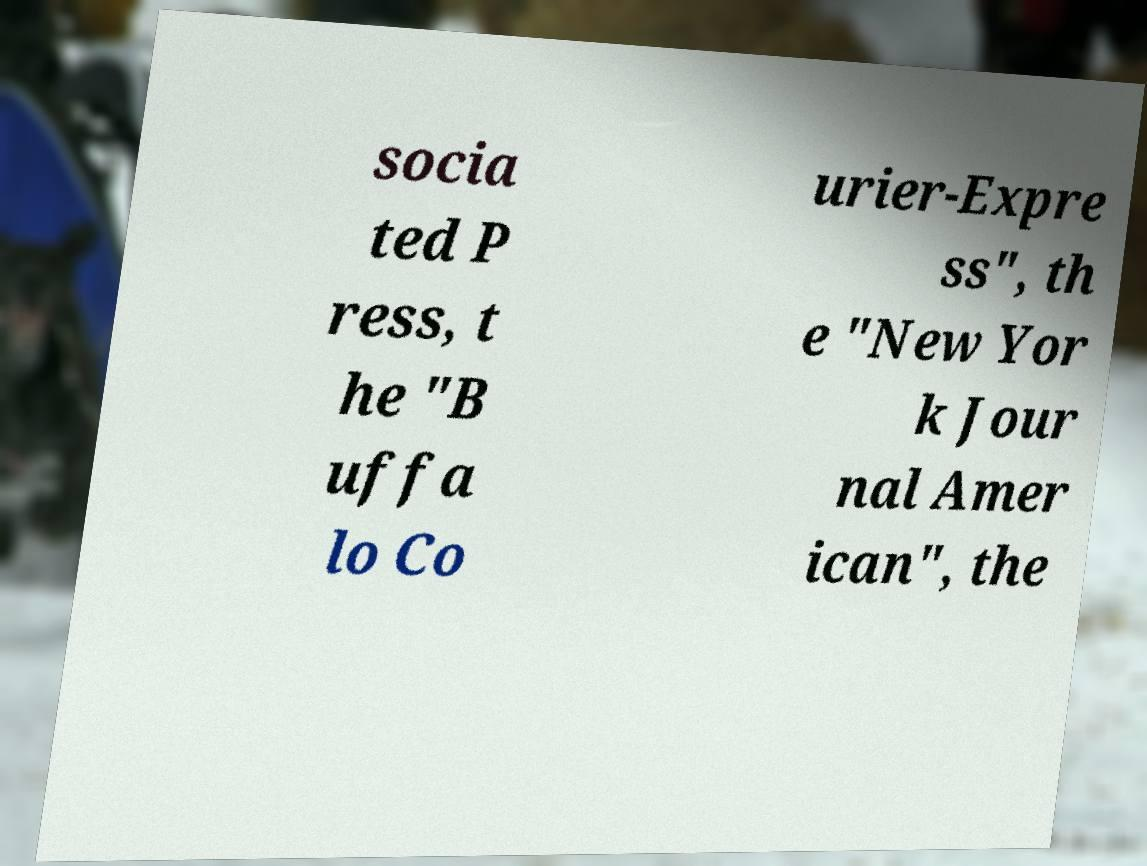Please identify and transcribe the text found in this image. socia ted P ress, t he "B uffa lo Co urier-Expre ss", th e "New Yor k Jour nal Amer ican", the 